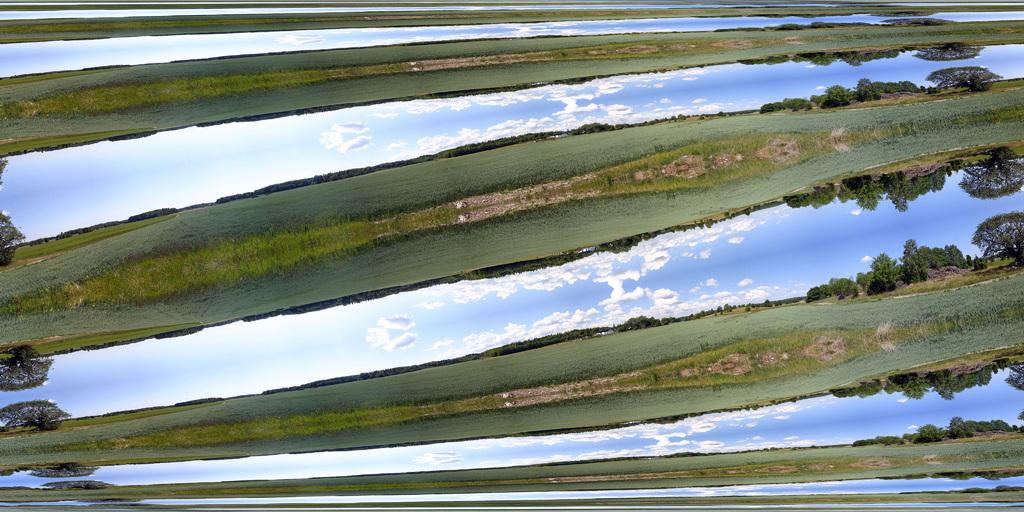What type of vegetation can be seen in the image? The image contains grass and trees. What part of the natural environment is visible in the image? The sky is visible in the image. What can be seen in the sky? Clouds are present in the sky. How many flowers can be seen in the image? There are no flowers present in the image. What color are the eyes of the lizards in the image? There are no lizards present in the image. 